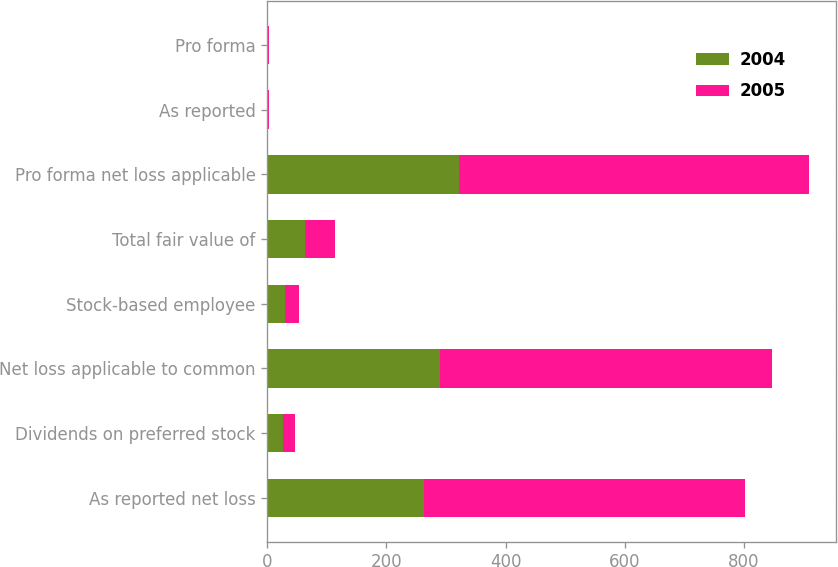Convert chart to OTSL. <chart><loc_0><loc_0><loc_500><loc_500><stacked_bar_chart><ecel><fcel>As reported net loss<fcel>Dividends on preferred stock<fcel>Net loss applicable to common<fcel>Stock-based employee<fcel>Total fair value of<fcel>Pro forma net loss applicable<fcel>As reported<fcel>Pro forma<nl><fcel>2004<fcel>262.9<fcel>26.3<fcel>289.2<fcel>30.2<fcel>62.6<fcel>321.6<fcel>0.68<fcel>0.76<nl><fcel>2005<fcel>538.4<fcel>19.8<fcel>558.2<fcel>22.5<fcel>51.3<fcel>587<fcel>1.34<fcel>1.41<nl></chart> 